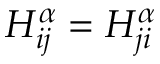<formula> <loc_0><loc_0><loc_500><loc_500>H _ { i j } ^ { \alpha } = H _ { j i } ^ { \alpha }</formula> 